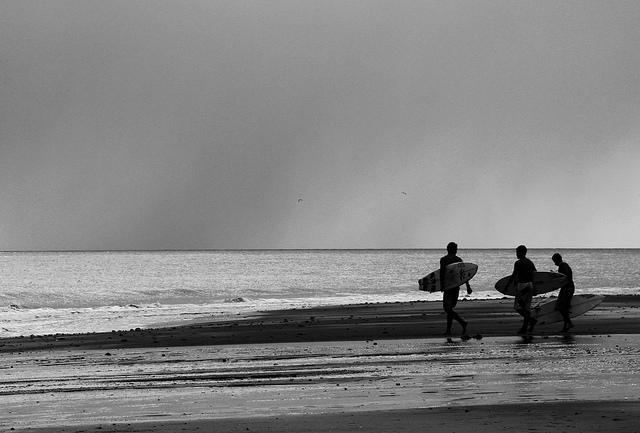Is the picture in color?
Write a very short answer. No. What are they carrying?
Be succinct. Surfboards. What are the people about to do?
Concise answer only. Surf. How many people aren't riding horses in this picture?
Keep it brief. 3. 